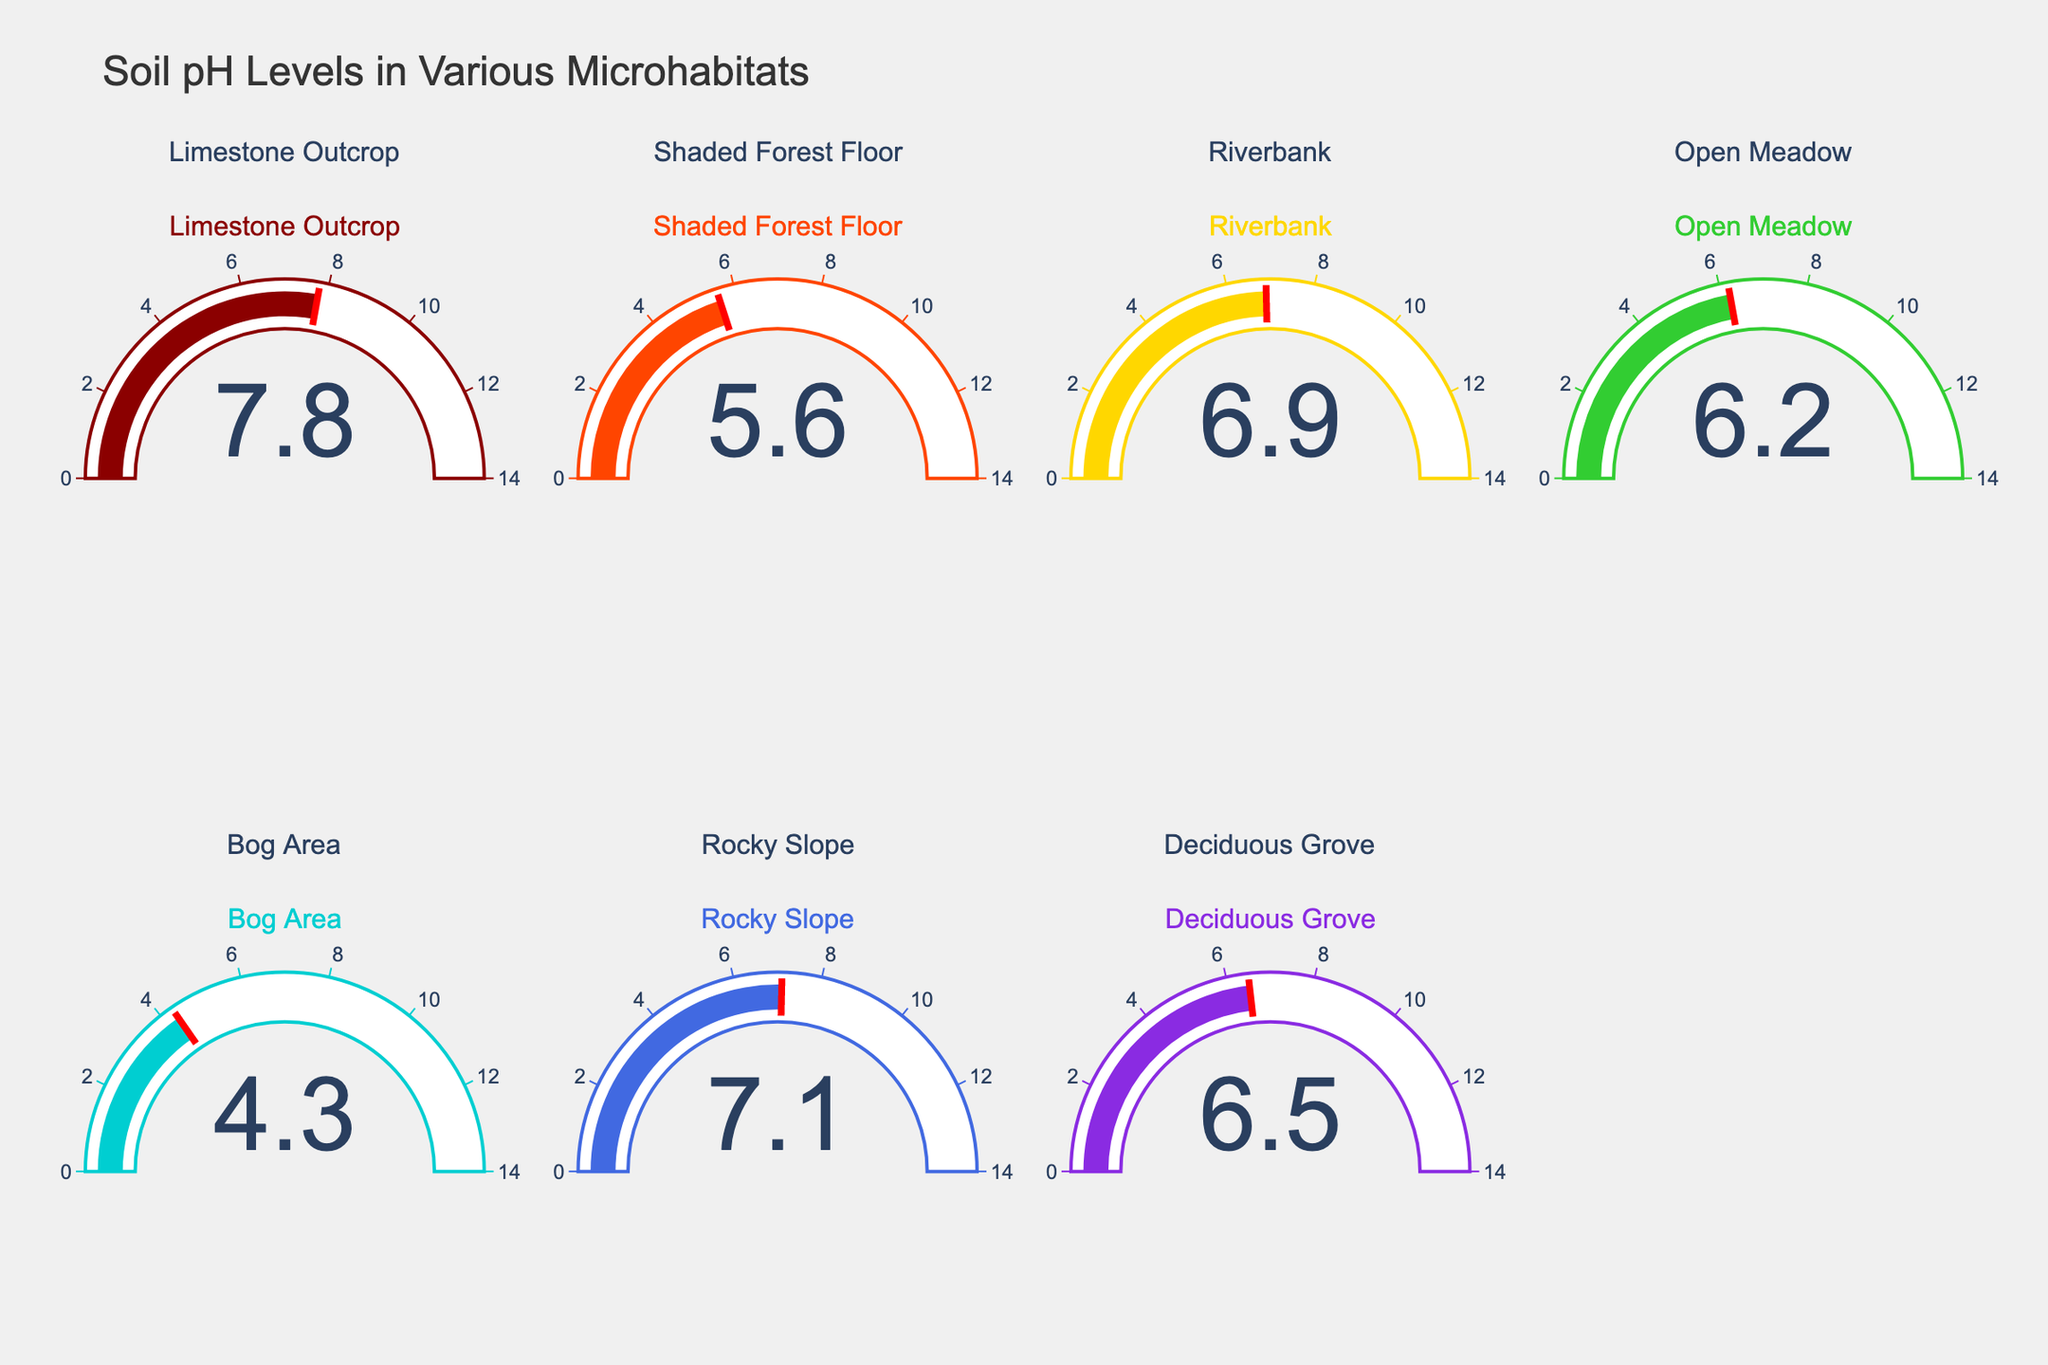What is the soil pH level of the limestone outcrop? The text in the gauge marked "Limestone Outcrop" shows the soil pH level.
Answer: 7.8 Which microhabitat has the lowest soil pH level? Checking all gauges, the one marked "Bog Area" shows the lowest value.
Answer: Bog Area How many microhabitats have a soil pH greater than 7.0? Gauges for "Limestone Outcrop" and "Rocky Slope" both show soil pH levels greater than 7.0.
Answer: 2 What is the range of soil pH levels across all microhabitats? The lowest value is 4.3 (Bog Area) and the highest is 7.8 (Limestone Outcrop). The range is 7.8 - 4.3 = 3.5.
Answer: 3.5 Which microhabitat has a soil pH level closest to neutral (pH 7)? The soil pH levels indicating closest to neutral can be found by checking each gauge. "Riverbank" with a pH of 6.9 is the closest to neutral.
Answer: Riverbank What colors represent the soil pH levels for microhabitats? Each gauge has a distinct colored bar. Specifically, the colors are (from the data): Limestone Outcrop (Dark Red), Shaded Forest Floor (Orange), Riverbank (Gold), Open Meadow (Green), Bog Area (Cyan), Rocky Slope (Royal Blue), Deciduous Grove (Blue). Each gauge can be checked for corresponding colors.
Answer: Various (Dark Red, Orange, Gold, Green, Cyan, Royal Blue, Blue) How does the pH of the shaded forest floor compare to that of the deciduous grove? The gauge shows the pH of the Shaded Forest Floor as 5.6 and the Deciduous Grove as 6.5. Hence, pH is lower in the Shaded Forest Floor.
Answer: Shaded Forest Floor is lower What is the average soil pH level across all the microhabitats? Sum all pH values and divide by the number of microhabitats. (7.8 + 5.6 + 6.9 + 6.2 + 4.3 + 7.1 + 6.5)/7 = 6.34.
Answer: 6.34 Is there any habitat with a soil pH of exactly 6.0? No gauge shows a value of exactly 6.0 upon checking all the gauges.
Answer: No 